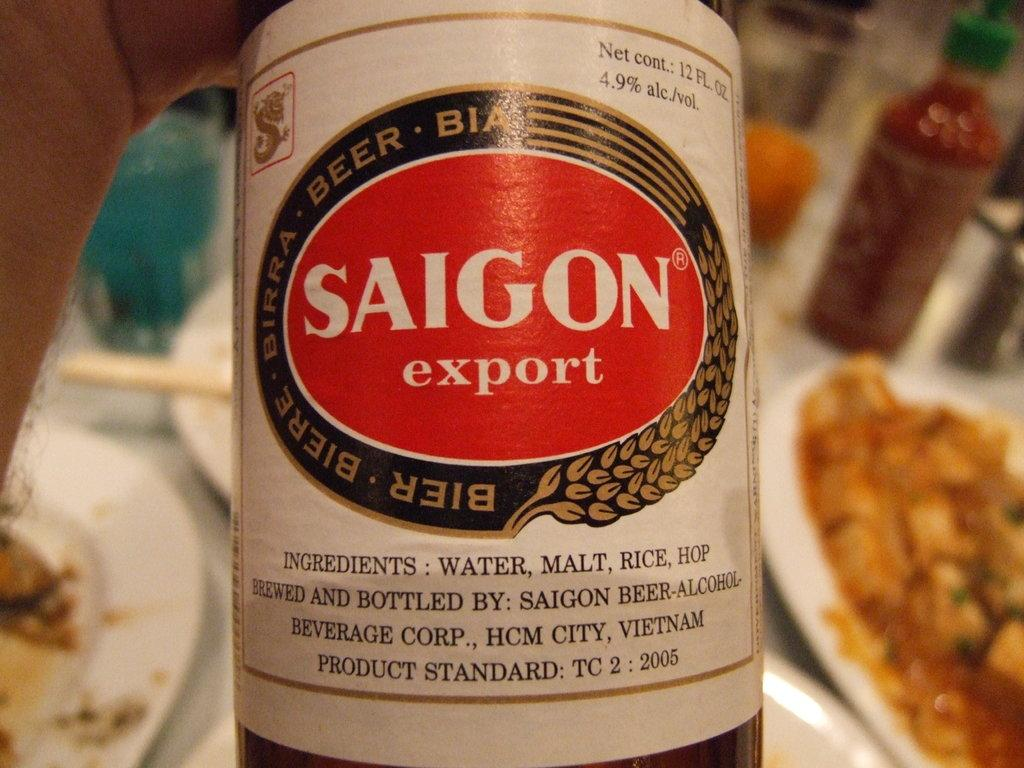Provide a one-sentence caption for the provided image. The label of Saigon export beer is white with a red oval. 